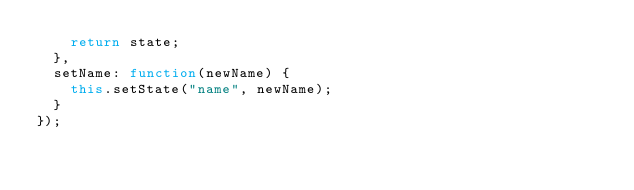Convert code to text. <code><loc_0><loc_0><loc_500><loc_500><_JavaScript_>    return state;
  },
  setName: function(newName) {
    this.setState("name", newName);
  }
});
</code> 